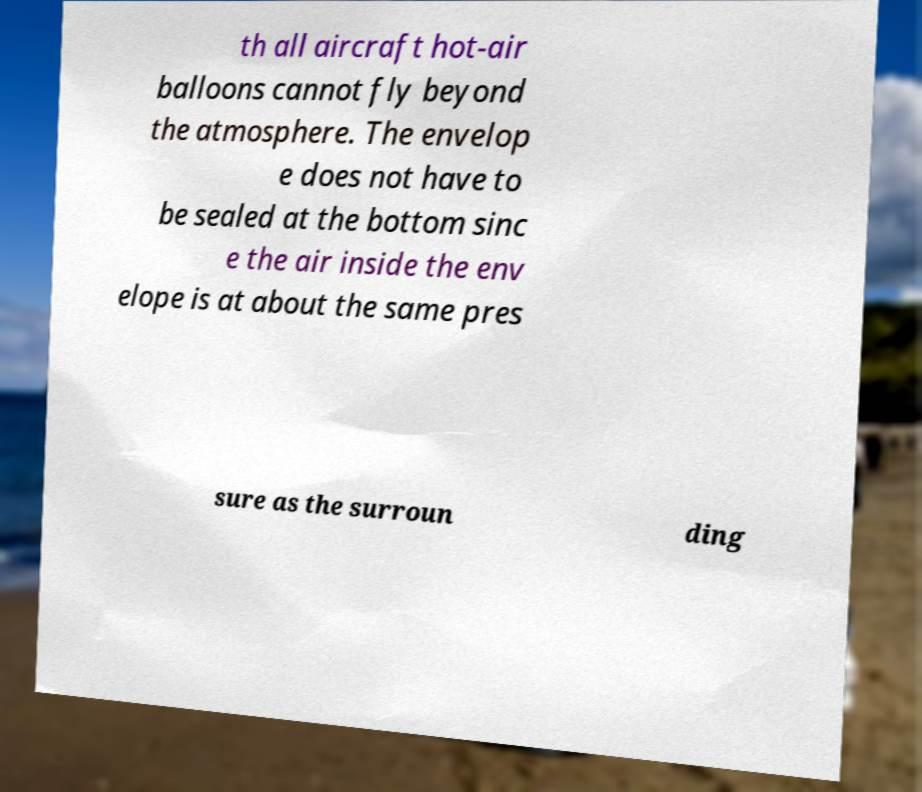Please identify and transcribe the text found in this image. th all aircraft hot-air balloons cannot fly beyond the atmosphere. The envelop e does not have to be sealed at the bottom sinc e the air inside the env elope is at about the same pres sure as the surroun ding 